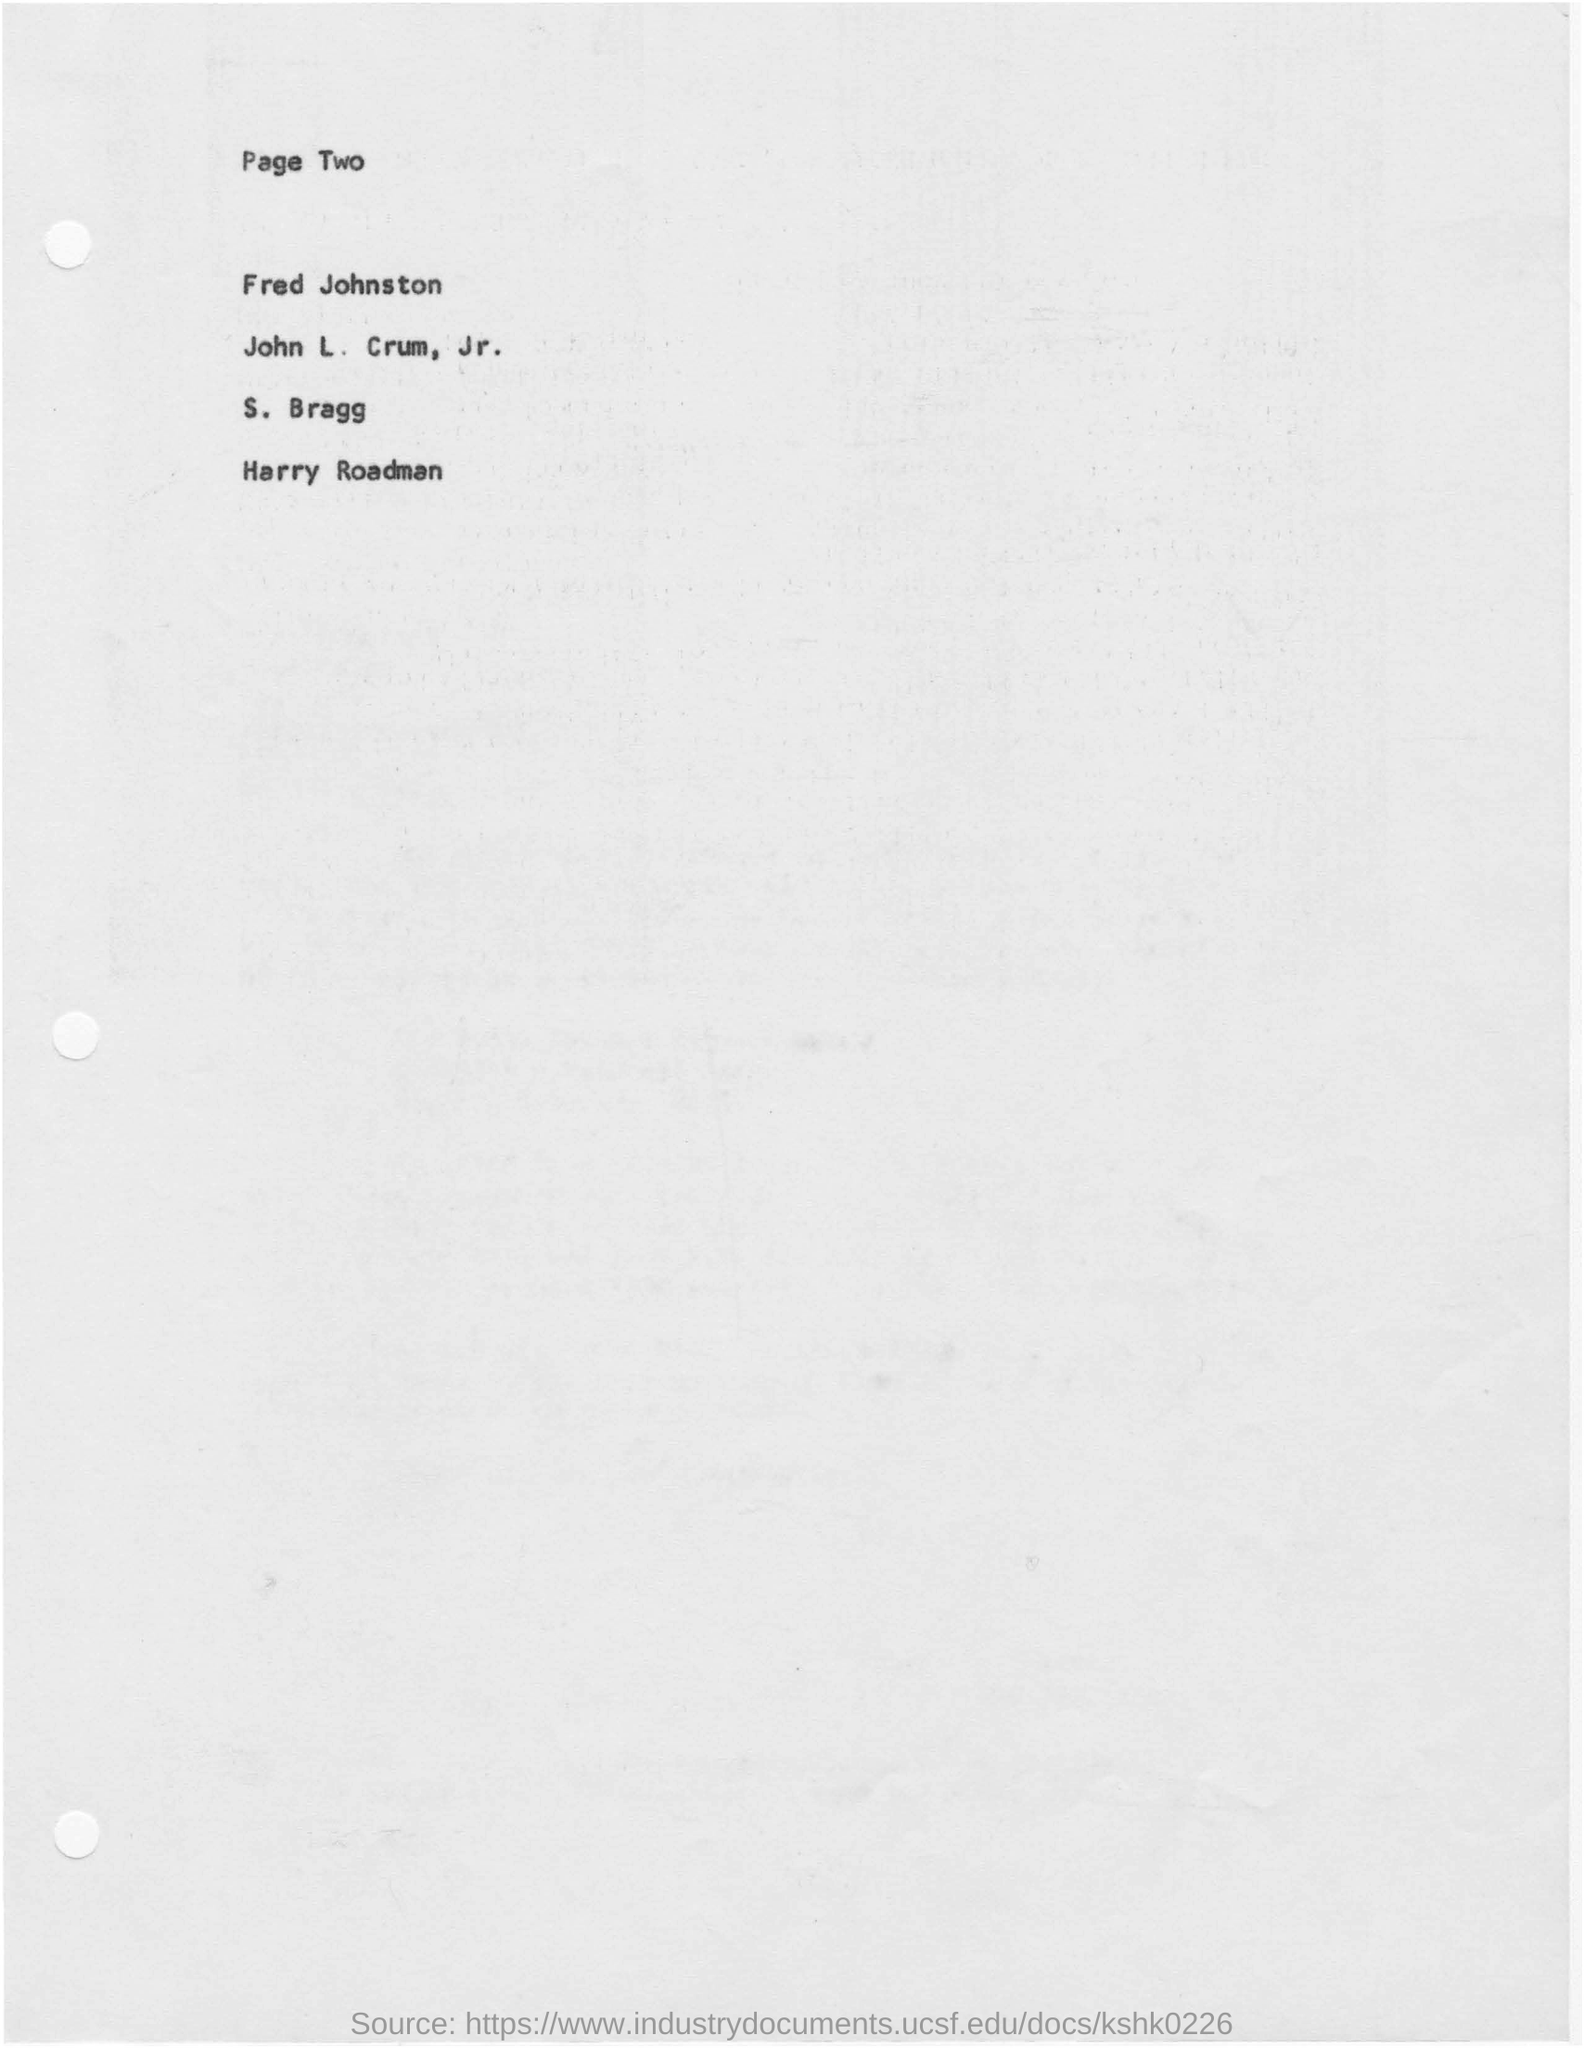Indicate a few pertinent items in this graphic. The last name in the list provided is "Roadman. The page number mentioned in this document is Page Two. The first person's name in the list given is Fred Johnston. 